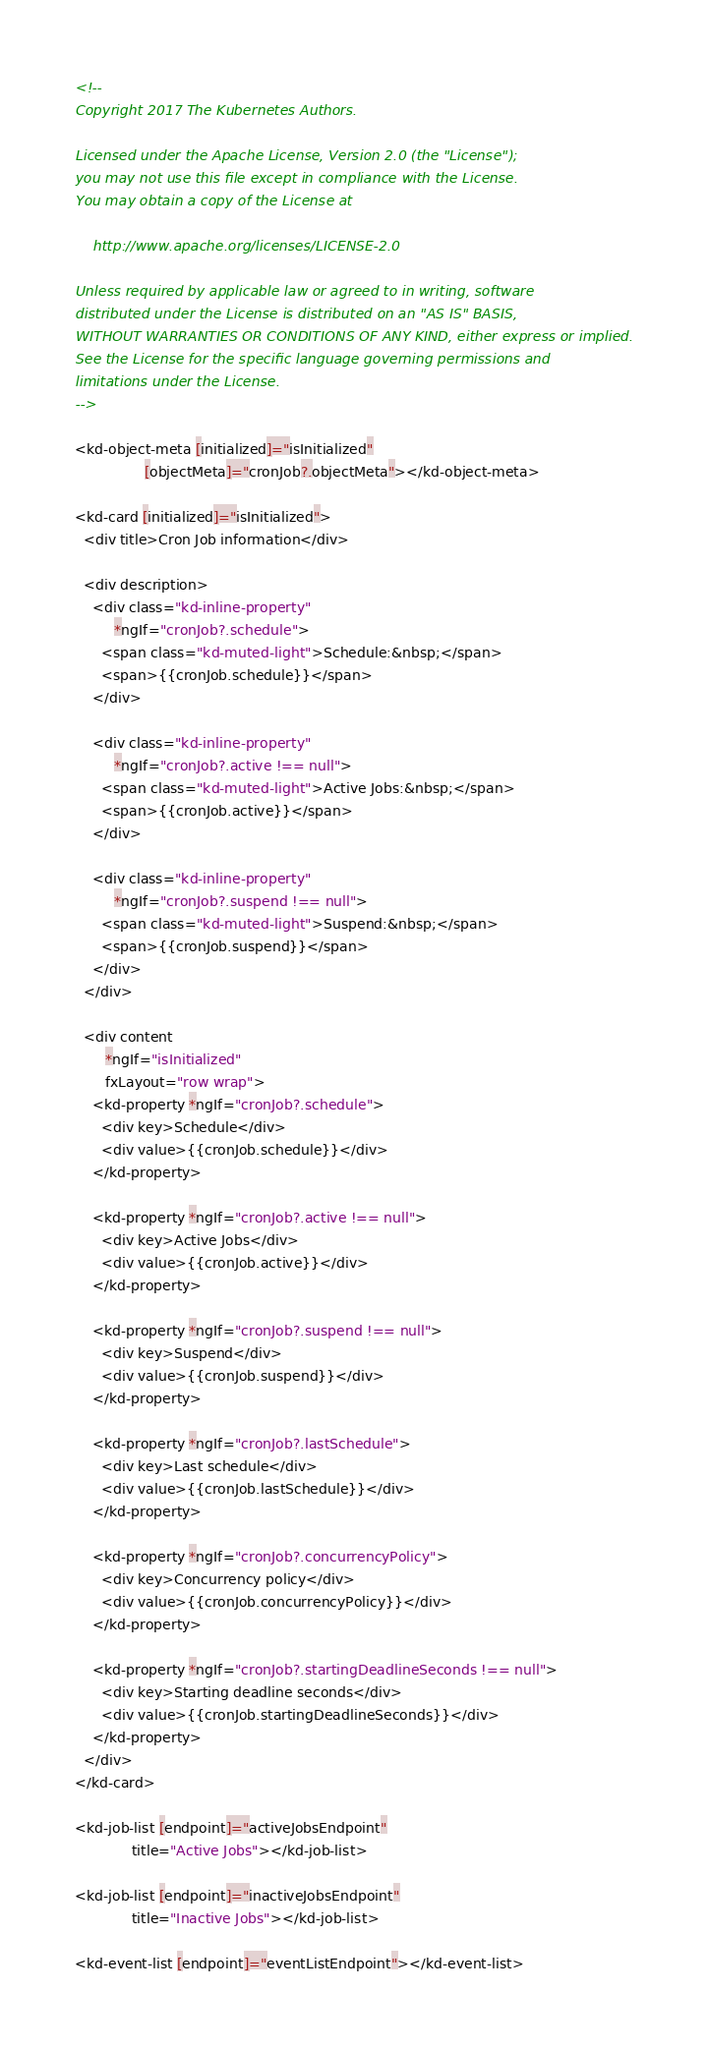Convert code to text. <code><loc_0><loc_0><loc_500><loc_500><_HTML_><!--
Copyright 2017 The Kubernetes Authors.

Licensed under the Apache License, Version 2.0 (the "License");
you may not use this file except in compliance with the License.
You may obtain a copy of the License at

    http://www.apache.org/licenses/LICENSE-2.0

Unless required by applicable law or agreed to in writing, software
distributed under the License is distributed on an "AS IS" BASIS,
WITHOUT WARRANTIES OR CONDITIONS OF ANY KIND, either express or implied.
See the License for the specific language governing permissions and
limitations under the License.
-->

<kd-object-meta [initialized]="isInitialized"
                [objectMeta]="cronJob?.objectMeta"></kd-object-meta>

<kd-card [initialized]="isInitialized">
  <div title>Cron Job information</div>

  <div description>
    <div class="kd-inline-property"
         *ngIf="cronJob?.schedule">
      <span class="kd-muted-light">Schedule:&nbsp;</span>
      <span>{{cronJob.schedule}}</span>
    </div>

    <div class="kd-inline-property"
         *ngIf="cronJob?.active !== null">
      <span class="kd-muted-light">Active Jobs:&nbsp;</span>
      <span>{{cronJob.active}}</span>
    </div>

    <div class="kd-inline-property"
         *ngIf="cronJob?.suspend !== null">
      <span class="kd-muted-light">Suspend:&nbsp;</span>
      <span>{{cronJob.suspend}}</span>
    </div>
  </div>

  <div content
       *ngIf="isInitialized"
       fxLayout="row wrap">
    <kd-property *ngIf="cronJob?.schedule">
      <div key>Schedule</div>
      <div value>{{cronJob.schedule}}</div>
    </kd-property>

    <kd-property *ngIf="cronJob?.active !== null">
      <div key>Active Jobs</div>
      <div value>{{cronJob.active}}</div>
    </kd-property>

    <kd-property *ngIf="cronJob?.suspend !== null">
      <div key>Suspend</div>
      <div value>{{cronJob.suspend}}</div>
    </kd-property>

    <kd-property *ngIf="cronJob?.lastSchedule">
      <div key>Last schedule</div>
      <div value>{{cronJob.lastSchedule}}</div>
    </kd-property>

    <kd-property *ngIf="cronJob?.concurrencyPolicy">
      <div key>Concurrency policy</div>
      <div value>{{cronJob.concurrencyPolicy}}</div>
    </kd-property>

    <kd-property *ngIf="cronJob?.startingDeadlineSeconds !== null">
      <div key>Starting deadline seconds</div>
      <div value>{{cronJob.startingDeadlineSeconds}}</div>
    </kd-property>
  </div>
</kd-card>

<kd-job-list [endpoint]="activeJobsEndpoint"
             title="Active Jobs"></kd-job-list>

<kd-job-list [endpoint]="inactiveJobsEndpoint"
             title="Inactive Jobs"></kd-job-list>

<kd-event-list [endpoint]="eventListEndpoint"></kd-event-list>
</code> 